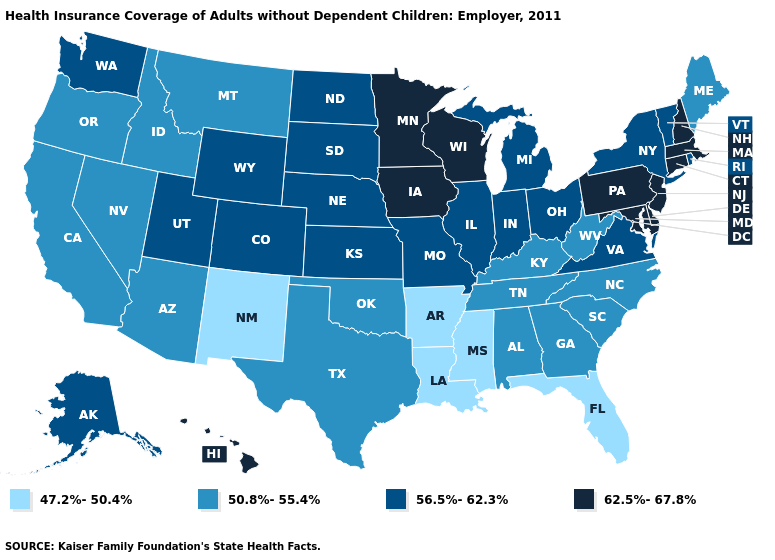Which states have the lowest value in the USA?
Answer briefly. Arkansas, Florida, Louisiana, Mississippi, New Mexico. Name the states that have a value in the range 50.8%-55.4%?
Quick response, please. Alabama, Arizona, California, Georgia, Idaho, Kentucky, Maine, Montana, Nevada, North Carolina, Oklahoma, Oregon, South Carolina, Tennessee, Texas, West Virginia. What is the value of Maine?
Short answer required. 50.8%-55.4%. Does the first symbol in the legend represent the smallest category?
Quick response, please. Yes. Is the legend a continuous bar?
Give a very brief answer. No. Name the states that have a value in the range 56.5%-62.3%?
Short answer required. Alaska, Colorado, Illinois, Indiana, Kansas, Michigan, Missouri, Nebraska, New York, North Dakota, Ohio, Rhode Island, South Dakota, Utah, Vermont, Virginia, Washington, Wyoming. What is the lowest value in the USA?
Short answer required. 47.2%-50.4%. Name the states that have a value in the range 50.8%-55.4%?
Answer briefly. Alabama, Arizona, California, Georgia, Idaho, Kentucky, Maine, Montana, Nevada, North Carolina, Oklahoma, Oregon, South Carolina, Tennessee, Texas, West Virginia. What is the value of Wisconsin?
Be succinct. 62.5%-67.8%. Does Hawaii have the highest value in the West?
Give a very brief answer. Yes. Among the states that border Missouri , does Iowa have the highest value?
Keep it brief. Yes. Which states have the lowest value in the MidWest?
Concise answer only. Illinois, Indiana, Kansas, Michigan, Missouri, Nebraska, North Dakota, Ohio, South Dakota. Name the states that have a value in the range 50.8%-55.4%?
Concise answer only. Alabama, Arizona, California, Georgia, Idaho, Kentucky, Maine, Montana, Nevada, North Carolina, Oklahoma, Oregon, South Carolina, Tennessee, Texas, West Virginia. What is the highest value in the Northeast ?
Give a very brief answer. 62.5%-67.8%. Does Illinois have a lower value than Massachusetts?
Write a very short answer. Yes. 